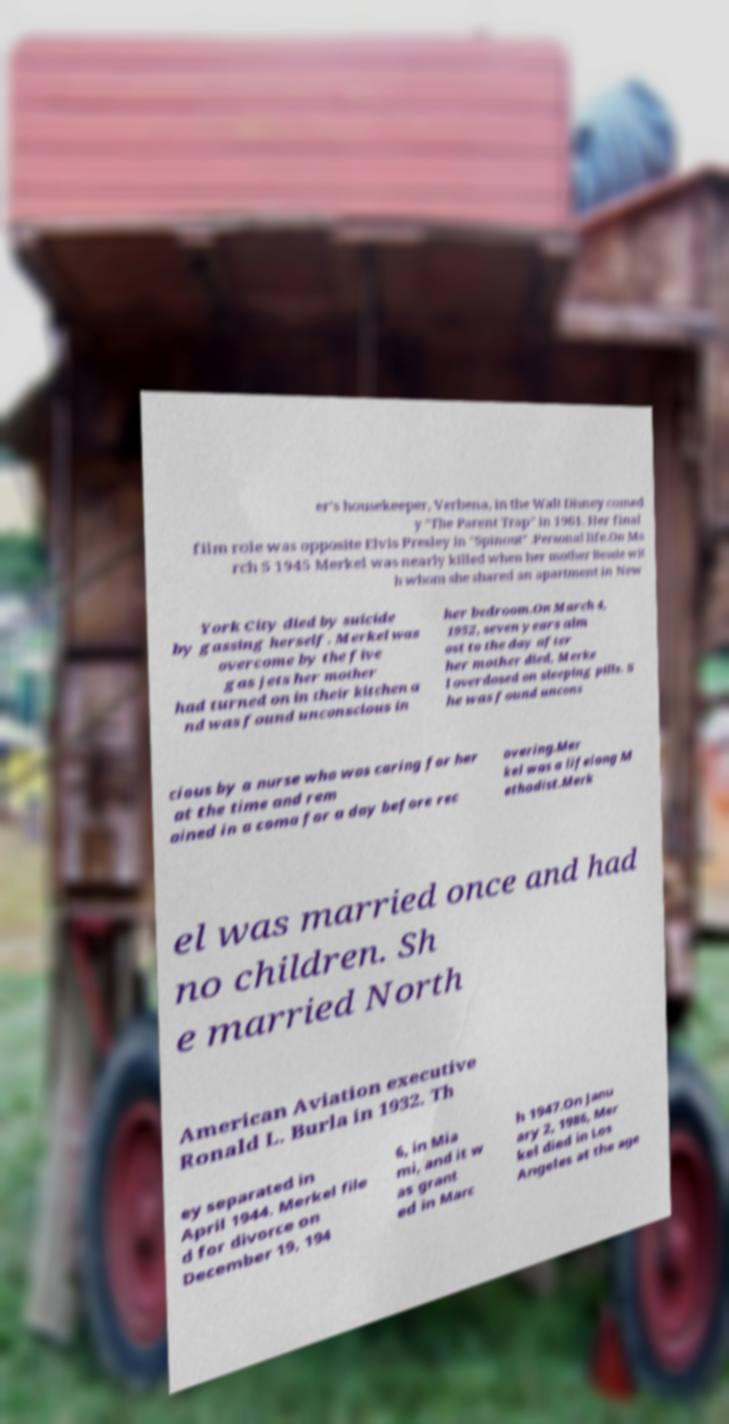Please read and relay the text visible in this image. What does it say? er's housekeeper, Verbena, in the Walt Disney comed y "The Parent Trap" in 1961. Her final film role was opposite Elvis Presley in "Spinout" .Personal life.On Ma rch 5 1945 Merkel was nearly killed when her mother Bessie wit h whom she shared an apartment in New York City died by suicide by gassing herself. Merkel was overcome by the five gas jets her mother had turned on in their kitchen a nd was found unconscious in her bedroom.On March 4, 1952, seven years alm ost to the day after her mother died, Merke l overdosed on sleeping pills. S he was found uncons cious by a nurse who was caring for her at the time and rem ained in a coma for a day before rec overing.Mer kel was a lifelong M ethodist.Merk el was married once and had no children. Sh e married North American Aviation executive Ronald L. Burla in 1932. Th ey separated in April 1944. Merkel file d for divorce on December 19, 194 6, in Mia mi, and it w as grant ed in Marc h 1947.On Janu ary 2, 1986, Mer kel died in Los Angeles at the age 